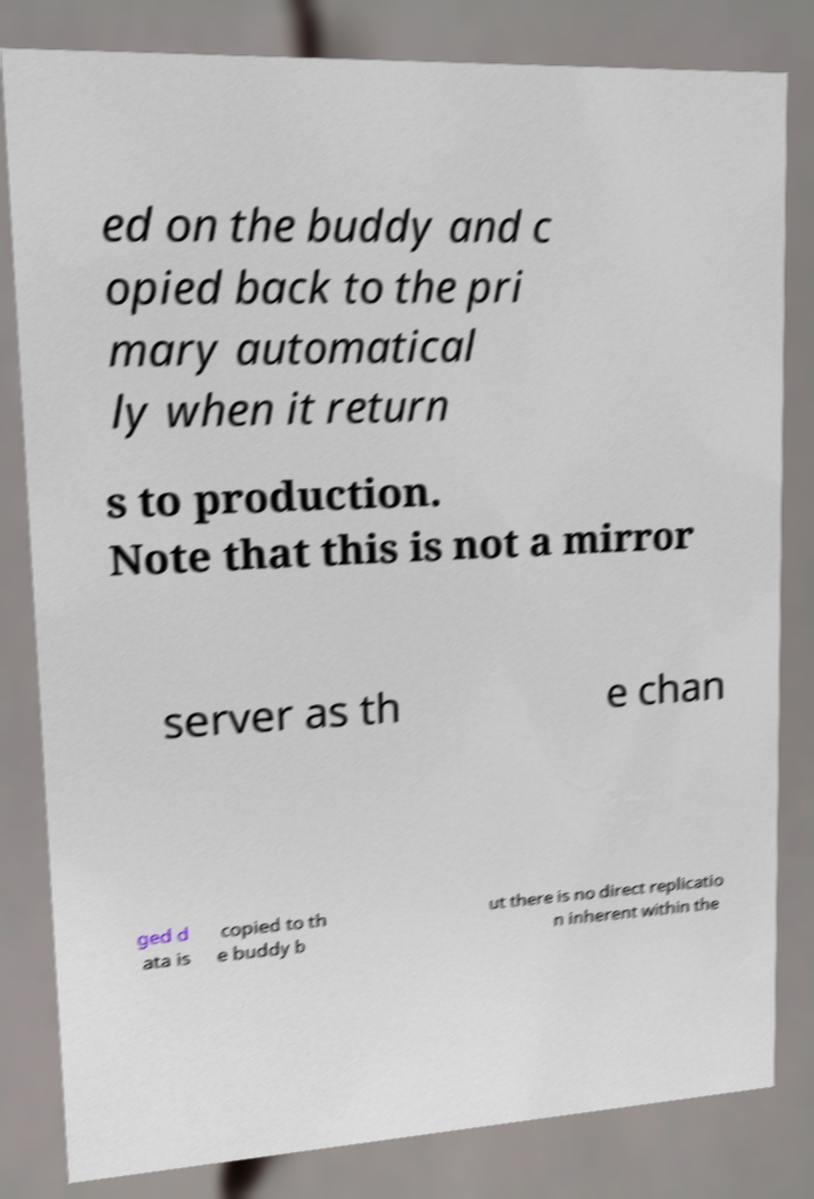What messages or text are displayed in this image? I need them in a readable, typed format. ed on the buddy and c opied back to the pri mary automatical ly when it return s to production. Note that this is not a mirror server as th e chan ged d ata is copied to th e buddy b ut there is no direct replicatio n inherent within the 